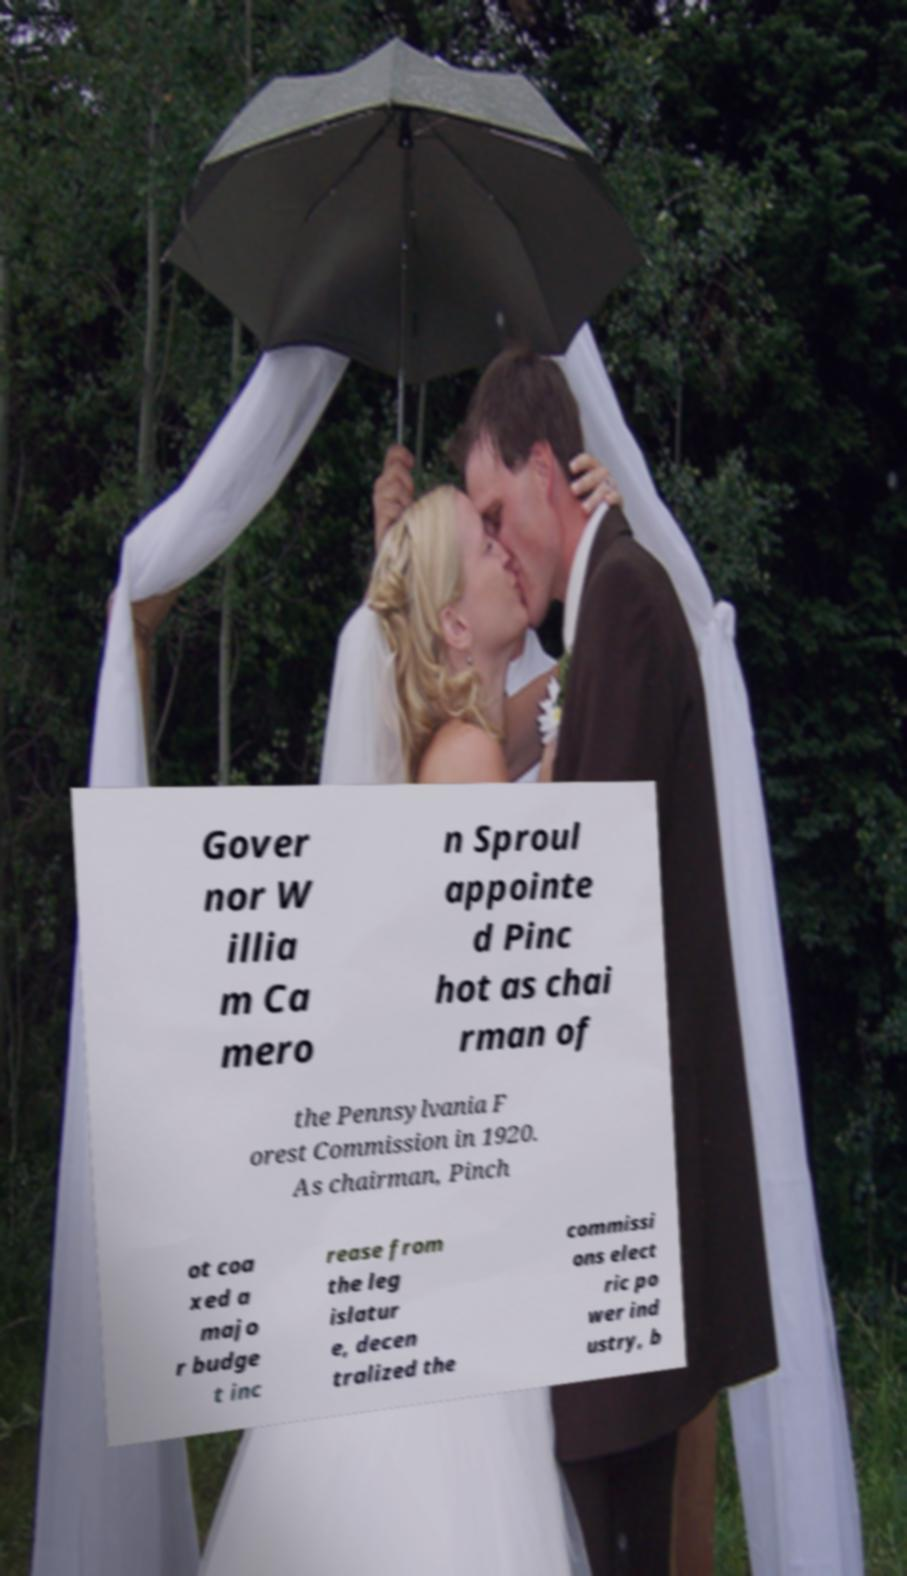I need the written content from this picture converted into text. Can you do that? Gover nor W illia m Ca mero n Sproul appointe d Pinc hot as chai rman of the Pennsylvania F orest Commission in 1920. As chairman, Pinch ot coa xed a majo r budge t inc rease from the leg islatur e, decen tralized the commissi ons elect ric po wer ind ustry, b 